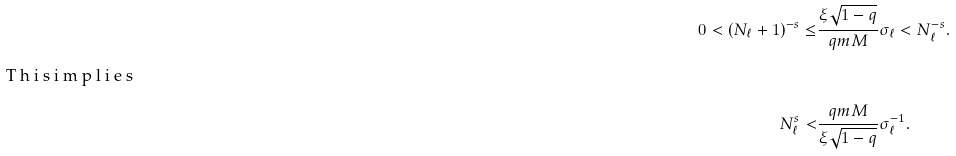<formula> <loc_0><loc_0><loc_500><loc_500>0 < ( N _ { \ell } + 1 ) ^ { - s } \leq & \frac { \xi \sqrt { 1 - q } } { \L q m M } \sigma _ { \ell } < N _ { \ell } ^ { - s } . \\ \intertext { T h i s i m p l i e s } N _ { \ell } ^ { s } < & \frac { \L q m M } { \xi \sqrt { 1 - q } } \sigma _ { \ell } ^ { - 1 } .</formula> 